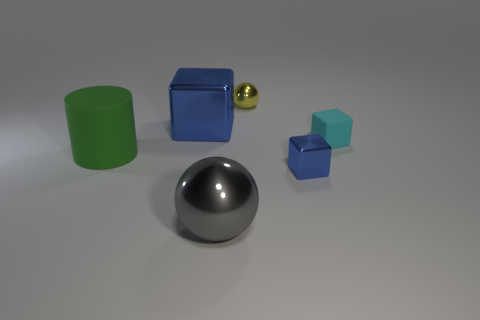What number of other objects are the same shape as the gray thing?
Provide a succinct answer. 1. What shape is the big metal object that is in front of the large rubber cylinder?
Provide a short and direct response. Sphere. Is there a large metallic object that is in front of the blue object that is to the right of the big blue metallic cube?
Offer a very short reply. Yes. What is the color of the shiny object that is behind the rubber block and to the right of the big blue thing?
Offer a very short reply. Yellow. There is a small shiny object that is in front of the metallic cube behind the small blue object; are there any big green matte objects that are in front of it?
Offer a terse response. No. What is the size of the other thing that is the same shape as the gray thing?
Your response must be concise. Small. Is there a large red matte block?
Your answer should be very brief. No. There is a big metallic block; does it have the same color as the small metal object in front of the large matte cylinder?
Give a very brief answer. Yes. There is a block that is to the left of the metallic object in front of the blue object to the right of the gray metallic object; what is its size?
Offer a terse response. Large. How many matte cubes have the same color as the large cylinder?
Your response must be concise. 0. 